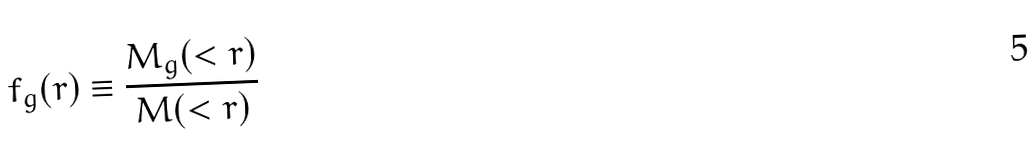Convert formula to latex. <formula><loc_0><loc_0><loc_500><loc_500>f _ { g } ( r ) \equiv \frac { M _ { g } ( < r ) } { M ( < r ) }</formula> 